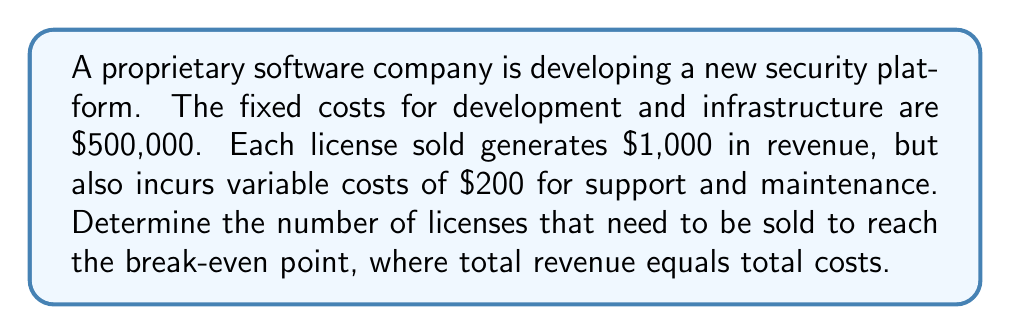Can you solve this math problem? Let's approach this step-by-step using a linear cost-revenue model:

1) Define variables:
   Let $x$ = number of licenses sold
   
2) Express the total revenue function:
   Revenue = Price per license × Number of licenses
   $R(x) = 1000x$

3) Express the total cost function:
   Total Cost = Fixed Costs + Variable Costs
   $C(x) = 500000 + 200x$

4) At the break-even point, total revenue equals total costs:
   $R(x) = C(x)$
   $1000x = 500000 + 200x$

5) Solve the equation:
   $1000x - 200x = 500000$
   $800x = 500000$
   $x = 500000 / 800$
   $x = 625$

Therefore, the company needs to sell 625 licenses to break even.

This demonstrates the importance of accurately pricing proprietary software to ensure profitability while maintaining control and security of the platform.
Answer: 625 licenses 